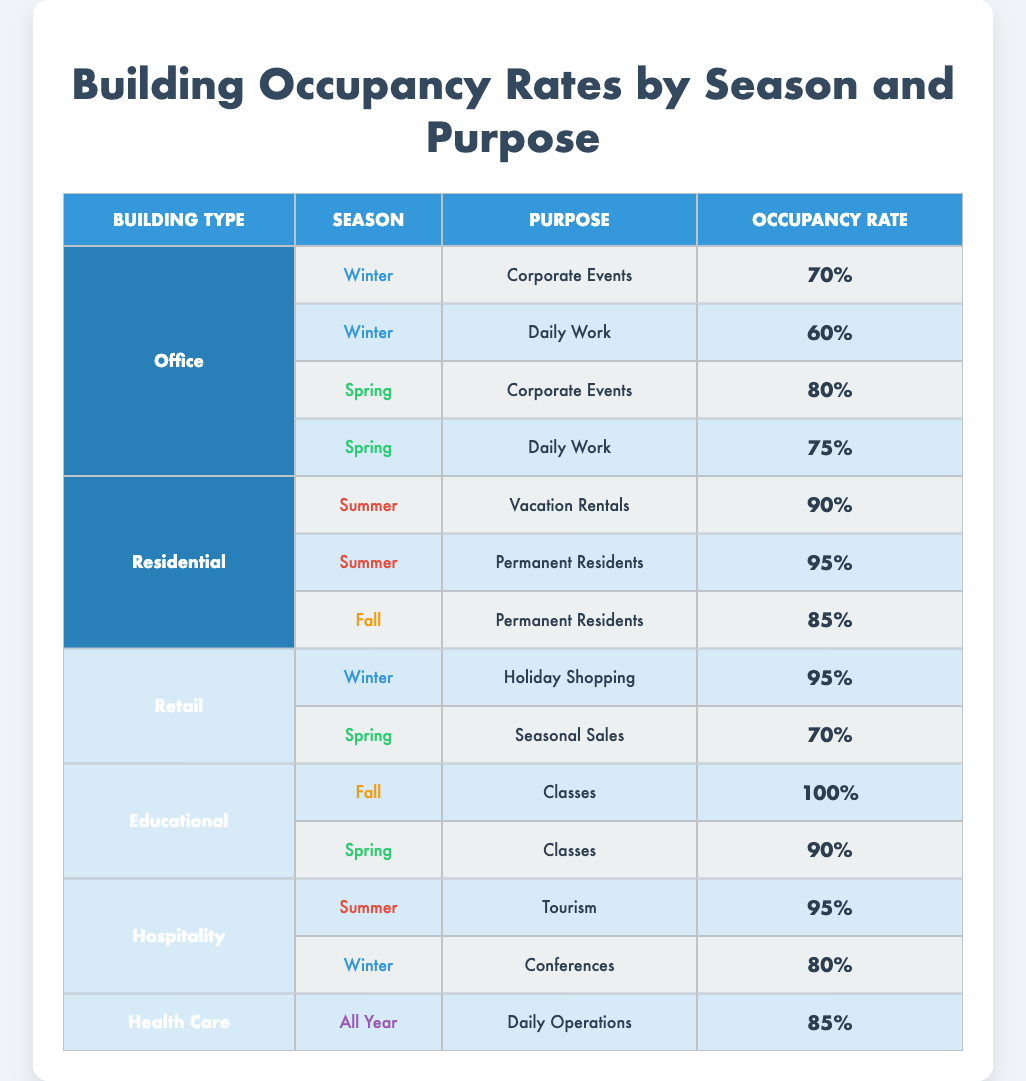What is the occupancy rate for Office buildings during Winter for Daily Work? Referring to the table, under the Office category for Winter, the row corresponding to Daily Work shows an occupancy rate of 60%.
Answer: 60% Which building type has the highest occupancy rate in Fall? Looking at the table, the Educational building type shows an occupancy rate of 100% during Fall, which is higher than any other type listed for that season.
Answer: 100% Is the occupancy rate for Hospitality buildings higher in Summer or Winter? The table shows that Hospitality buildings maintain an occupancy rate of 95% in Summer and 80% in Winter. Since 95% is greater than 80%, the Summer rate is higher.
Answer: Yes, higher in Summer What is the average occupancy rate for Residential buildings? The occupancy rates for Residential buildings are 90%, 95%, and 85%. To find the average, we add these rates together: (90 + 95 + 85) = 270. Dividing by 3 (the number of entries), we get 270/3 = 90.
Answer: 90 Do Retail buildings have a higher occupancy rate during Winter than during Spring? Referring to the table, Retail buildings have an occupancy rate of 95% during Winter for Holiday Shopping and 70% during Spring for Seasonal Sales. Since 95% is greater than 70%, this statement is true.
Answer: Yes, higher in Winter What is the difference in occupancy rates for Educational buildings between Fall and Spring? The occupancy rates for Educational buildings are 100% in Fall and 90% in Spring. To find the difference, we subtract Spring's occupancy rate from Fall's: 100 - 90 = 10%.
Answer: 10% Which purpose has the highest occupancy rate for Office buildings in Spring? In the Office category during Spring, the purposes listed are Corporate Events at 80% and Daily Work at 75%. The higher is Corporate Events at 80%.
Answer: Corporate Events at 80% Is there a building type that has a 95% occupancy rate, and if so, which season? Yes, both Residential buildings (for Vacation Rentals and Permanent Residents) and Hospitality buildings (for Tourism) have a 95% occupancy rate. Residential buildings reach this in Summer, while Hospitality achieves this in Summer as well.
Answer: Yes, Residential and Hospitality in Summer 